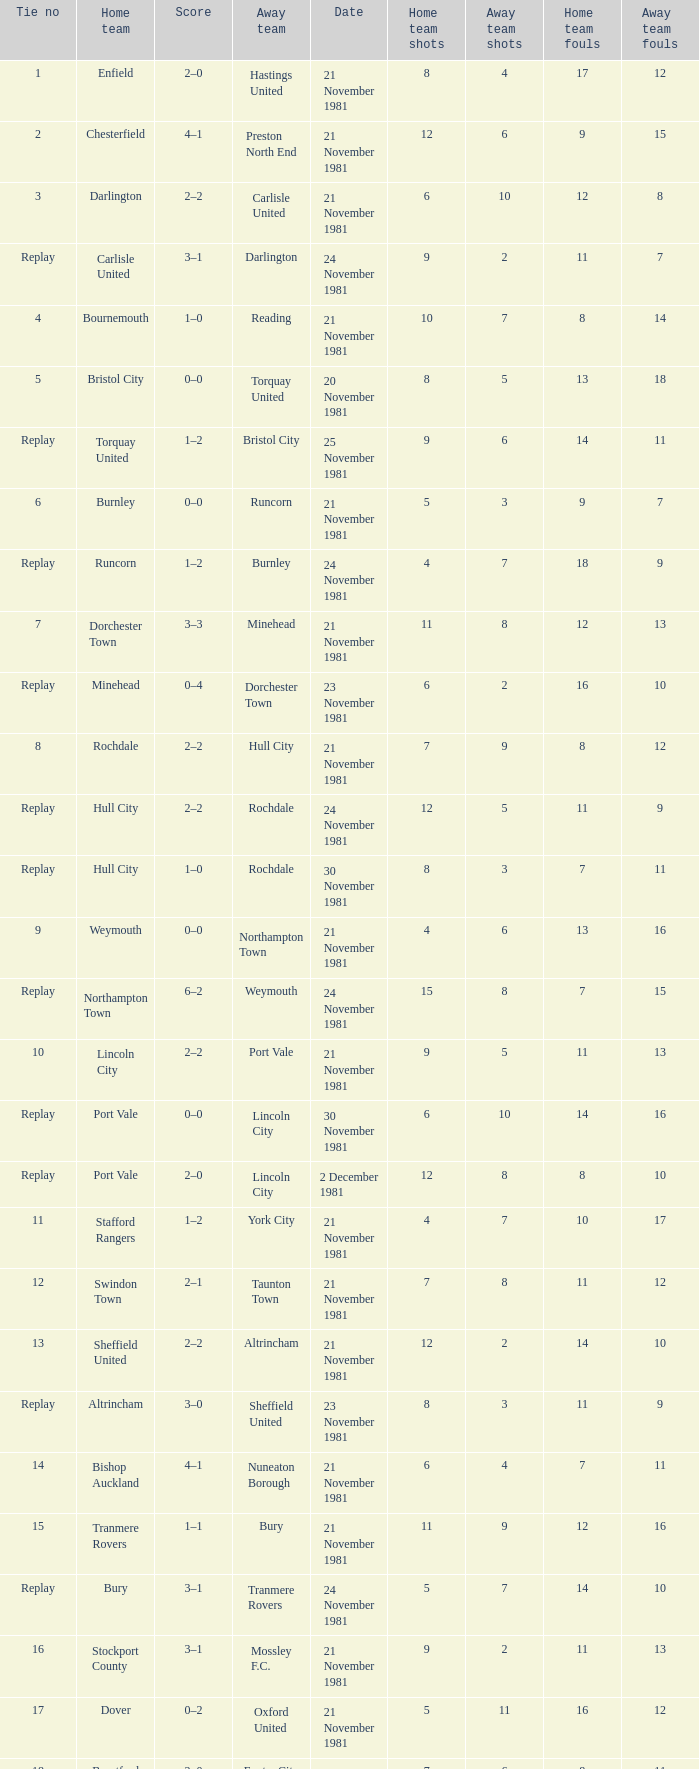Give me the full table as a dictionary. {'header': ['Tie no', 'Home team', 'Score', 'Away team', 'Date', 'Home team shots', 'Away team shots', 'Home team fouls', 'Away team fouls'], 'rows': [['1', 'Enfield', '2–0', 'Hastings United', '21 November 1981', '8', '4', '17', '12'], ['2', 'Chesterfield', '4–1', 'Preston North End', '21 November 1981', '12', '6', '9', '15'], ['3', 'Darlington', '2–2', 'Carlisle United', '21 November 1981', '6', '10', '12', '8'], ['Replay', 'Carlisle United', '3–1', 'Darlington', '24 November 1981', '9', '2', '11', '7'], ['4', 'Bournemouth', '1–0', 'Reading', '21 November 1981', '10', '7', '8', '14'], ['5', 'Bristol City', '0–0', 'Torquay United', '20 November 1981', '8', '5', '13', '18'], ['Replay', 'Torquay United', '1–2', 'Bristol City', '25 November 1981', '9', '6', '14', '11'], ['6', 'Burnley', '0–0', 'Runcorn', '21 November 1981', '5', '3', '9', '7'], ['Replay', 'Runcorn', '1–2', 'Burnley', '24 November 1981', '4', '7', '18', '9'], ['7', 'Dorchester Town', '3–3', 'Minehead', '21 November 1981', '11', '8', '12', '13'], ['Replay', 'Minehead', '0–4', 'Dorchester Town', '23 November 1981', '6', '2', '16', '10'], ['8', 'Rochdale', '2–2', 'Hull City', '21 November 1981', '7', '9', '8', '12'], ['Replay', 'Hull City', '2–2', 'Rochdale', '24 November 1981', '12', '5', '11', '9'], ['Replay', 'Hull City', '1–0', 'Rochdale', '30 November 1981', '8', '3', '7', '11'], ['9', 'Weymouth', '0–0', 'Northampton Town', '21 November 1981', '4', '6', '13', '16'], ['Replay', 'Northampton Town', '6–2', 'Weymouth', '24 November 1981', '15', '8', '7', '15'], ['10', 'Lincoln City', '2–2', 'Port Vale', '21 November 1981', '9', '5', '11', '13'], ['Replay', 'Port Vale', '0–0', 'Lincoln City', '30 November 1981', '6', '10', '14', '16'], ['Replay', 'Port Vale', '2–0', 'Lincoln City', '2 December 1981', '12', '8', '8', '10'], ['11', 'Stafford Rangers', '1–2', 'York City', '21 November 1981', '4', '7', '10', '17'], ['12', 'Swindon Town', '2–1', 'Taunton Town', '21 November 1981', '7', '8', '11', '12'], ['13', 'Sheffield United', '2–2', 'Altrincham', '21 November 1981', '12', '2', '14', '10'], ['Replay', 'Altrincham', '3–0', 'Sheffield United', '23 November 1981', '8', '3', '11', '9'], ['14', 'Bishop Auckland', '4–1', 'Nuneaton Borough', '21 November 1981', '6', '4', '7', '11'], ['15', 'Tranmere Rovers', '1–1', 'Bury', '21 November 1981', '11', '9', '12', '16'], ['Replay', 'Bury', '3–1', 'Tranmere Rovers', '24 November 1981', '5', '7', '14', '10'], ['16', 'Stockport County', '3–1', 'Mossley F.C.', '21 November 1981', '9', '2', '11', '13'], ['17', 'Dover', '0–2', 'Oxford United', '21 November 1981', '5', '11', '16', '12'], ['18', 'Brentford', '2–0', 'Exeter City', '21 November 1981', '7', '6', '8', '11'], ['19', 'Bristol Rovers', '1–2', 'Fulham', '21 November 1981', '6', '7', '13', '17'], ['20', 'Portsmouth', '1–1', 'Millwall', '21 November 1981', '8', '9', '10', '16'], ['Replay', 'Millwall', '3–2', 'Portsmouth', '25 November 1981', '10', '8', '11', '14'], ['21', 'Plymouth Argyle', '0–0', 'Gillingham', '21 November 1981', '3', '12', '13', '19'], ['Replay', 'Gillingham', '1–0', 'Plymouth Argyle', '24 November 1981', '9', '7', '16', '15'], ['22', 'Penrith', '1–0', 'Chester', '21 November 1981', '4', '8', '12', '14'], ['23', 'Scunthorpe United', '1–0', 'Bradford City', '21 November 1981', '9', '4', '9', '12'], ['24', 'Blyth Spartans', '1–2', 'Walsall', '21 November 1981', '3', '11', '13', '9'], ['25', 'Bedford Town', '0–2', 'Wimbledon', '21 November 1981', '5', '7', '9', '8'], ['26', 'Mansfield Town', '0–1', 'Doncaster Rovers', '21 November 1981', '6', '11', '15', '17'], ['27', 'Halifax Town', '0–3', 'Peterborough United', '21 November 1981', '7', '9', '12', '14'], ['28', 'Workington', '1–1', 'Huddersfield Town', '21 November 1981', '6', '4', '10', '16'], ['Replay', 'Huddersfield Town', '5–0', 'Workington', '24 November 1981', '11', '4', '9', '14'], ['29', 'Hereford United', '3–1', 'Southend United', '21 November 1981', '9', '5', '10', '11'], ['30', "Bishop's Stortford", '2–2', 'Sutton United', '21 November 1981', '7', '4', '14', '7'], ['Replay', 'Sutton United', '2–1', "Bishop's Stortford", '24 November 1981', '9', '6', '11', '13'], ['31', 'Bideford', '1–2', 'Barking', '21 November 1981', '2', '8', '13', '11'], ['32', 'Aldershot', '2–0', 'Leytonstone/Ilford', '21 November 1981', '11', '7', '8', '6'], ['33', 'Horden CW', '0–1', 'Blackpool', '21 November 1981', '3', '11', '12', '9'], ['34', 'Wigan Athletic', '2–2', 'Hartlepool United', '21 November 1981', '10', '9', '16', '11'], ['Replay', 'Hartlepool United', '1–0', 'Wigan Athletic', '25 November 1981', '6', '4', '15', '9'], ['35', 'Boston United', '0–1', 'Kettering Town', '21 November 1981', '3', '9', '12', '15'], ['36', 'Harlow Town', '0–0', 'Barnet', '21 November 1981', '5', '7', '10', '18'], ['Replay', 'Barnet', '1–0', 'Harlow Town', '24 November 1981', '8', '4', '9', '15'], ['37', 'Colchester United', '2–0', 'Newport County', '21 November 1981', '9', '6', '14', '17'], ['38', 'Hendon', '1–1', 'Wycombe Wanderers', '21 November 1981', '6', '8', '11', '9'], ['Replay', 'Wycombe Wanderers', '2–0', 'Hendon', '24 November 1981', '11', '7', '8', '16'], ['39', 'Dagenham', '2–2', 'Yeovil Town', '21 November 1981', '5', '12', '16', '12'], ['Replay', 'Yeovil Town', '0–1', 'Dagenham', '25 November 1981', '10', '7', '8', '13'], ['40', 'Willenhall Town', '0–1', 'Crewe Alexandra', '21 November 1981', '3', '10', '11', '13']]} On what date was tie number 4? 21 November 1981. 